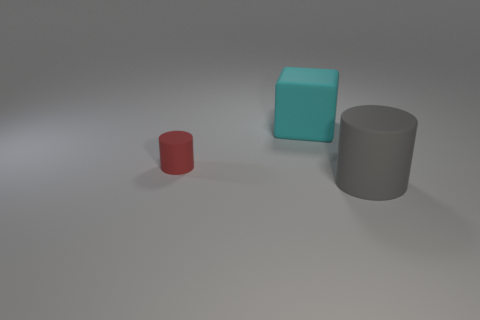Add 3 large gray shiny things. How many objects exist? 6 Subtract all red cylinders. How many cylinders are left? 1 Subtract all cylinders. How many objects are left? 1 Subtract all red cylinders. Subtract all gray cylinders. How many objects are left? 1 Add 2 large cubes. How many large cubes are left? 3 Add 2 tiny brown things. How many tiny brown things exist? 2 Subtract 0 blue balls. How many objects are left? 3 Subtract all gray cylinders. Subtract all gray balls. How many cylinders are left? 1 